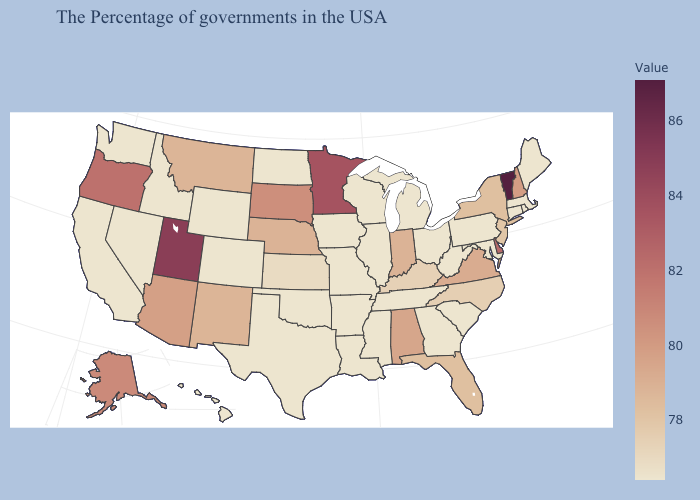Does Kentucky have a higher value than Delaware?
Answer briefly. No. Which states have the lowest value in the Northeast?
Concise answer only. Maine, Massachusetts, Rhode Island, Connecticut, Pennsylvania. 